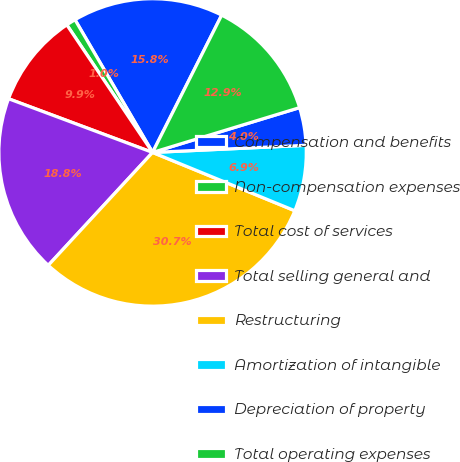Convert chart to OTSL. <chart><loc_0><loc_0><loc_500><loc_500><pie_chart><fcel>Compensation and benefits<fcel>Non-compensation expenses<fcel>Total cost of services<fcel>Total selling general and<fcel>Restructuring<fcel>Amortization of intangible<fcel>Depreciation of property<fcel>Total operating expenses<nl><fcel>15.84%<fcel>1.0%<fcel>9.9%<fcel>18.81%<fcel>30.68%<fcel>6.93%<fcel>3.97%<fcel>12.87%<nl></chart> 